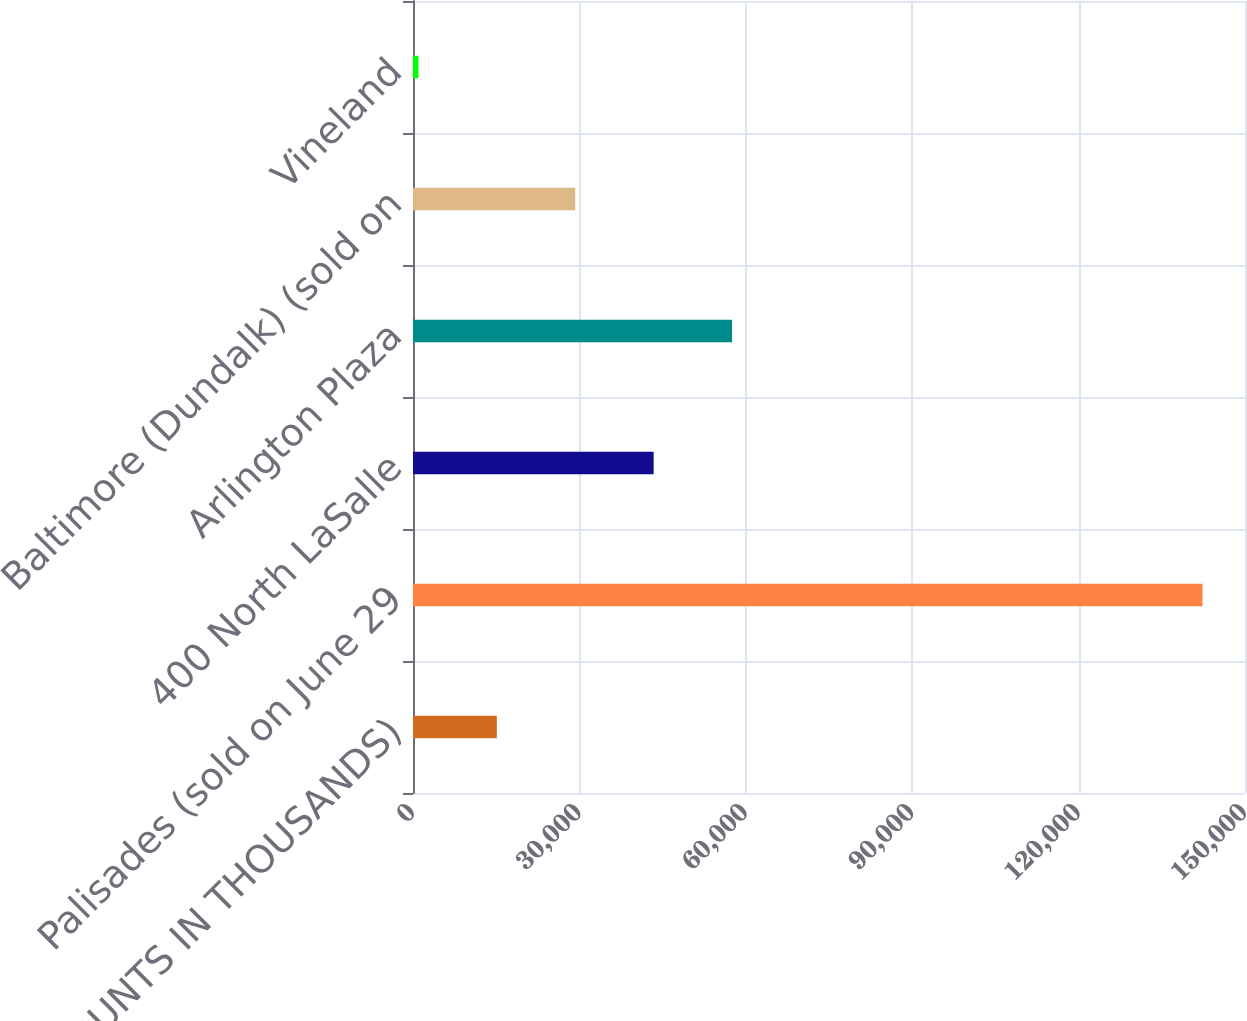Convert chart to OTSL. <chart><loc_0><loc_0><loc_500><loc_500><bar_chart><fcel>(AMOUNTS IN THOUSANDS)<fcel>Palisades (sold on June 29<fcel>400 North LaSalle<fcel>Arlington Plaza<fcel>Baltimore (Dundalk) (sold on<fcel>Vineland<nl><fcel>15113.5<fcel>142333<fcel>43384.5<fcel>57520<fcel>29249<fcel>978<nl></chart> 